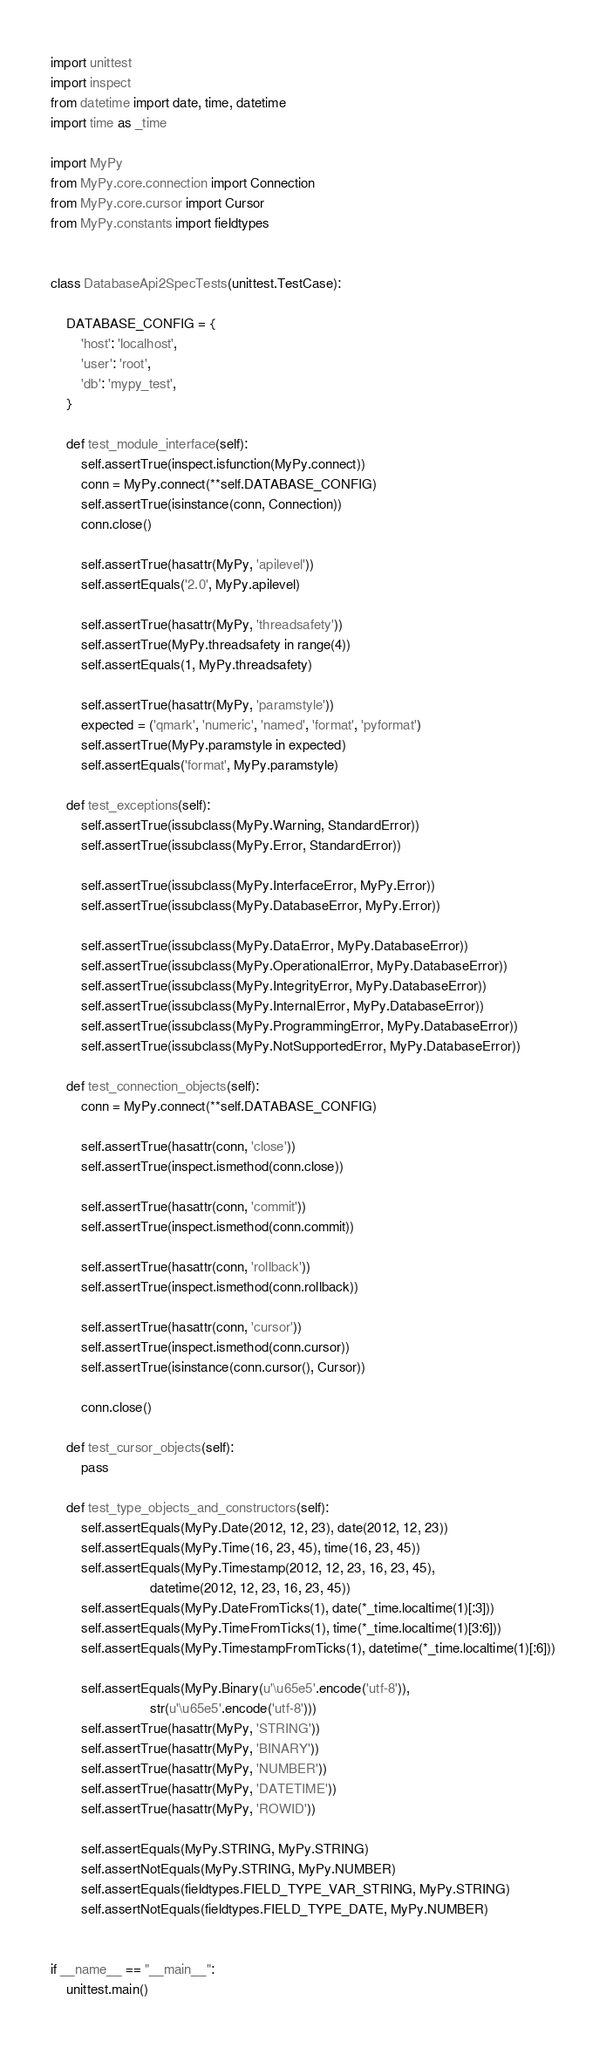Convert code to text. <code><loc_0><loc_0><loc_500><loc_500><_Python_>import unittest   
import inspect
from datetime import date, time, datetime
import time as _time

import MyPy
from MyPy.core.connection import Connection
from MyPy.core.cursor import Cursor
from MyPy.constants import fieldtypes


class DatabaseApi2SpecTests(unittest.TestCase):
    
    DATABASE_CONFIG = {
        'host': 'localhost',
        'user': 'root',
        'db': 'mypy_test',
    }
     
    def test_module_interface(self):
        self.assertTrue(inspect.isfunction(MyPy.connect))
        conn = MyPy.connect(**self.DATABASE_CONFIG)
        self.assertTrue(isinstance(conn, Connection))
        conn.close()

        self.assertTrue(hasattr(MyPy, 'apilevel'))
        self.assertEquals('2.0', MyPy.apilevel)
        
        self.assertTrue(hasattr(MyPy, 'threadsafety'))
        self.assertTrue(MyPy.threadsafety in range(4))
        self.assertEquals(1, MyPy.threadsafety)
        
        self.assertTrue(hasattr(MyPy, 'paramstyle'))
        expected = ('qmark', 'numeric', 'named', 'format', 'pyformat')
        self.assertTrue(MyPy.paramstyle in expected)
        self.assertEquals('format', MyPy.paramstyle)
        
    def test_exceptions(self):
        self.assertTrue(issubclass(MyPy.Warning, StandardError))
        self.assertTrue(issubclass(MyPy.Error, StandardError))
        
        self.assertTrue(issubclass(MyPy.InterfaceError, MyPy.Error))
        self.assertTrue(issubclass(MyPy.DatabaseError, MyPy.Error))

        self.assertTrue(issubclass(MyPy.DataError, MyPy.DatabaseError))
        self.assertTrue(issubclass(MyPy.OperationalError, MyPy.DatabaseError))
        self.assertTrue(issubclass(MyPy.IntegrityError, MyPy.DatabaseError))
        self.assertTrue(issubclass(MyPy.InternalError, MyPy.DatabaseError))
        self.assertTrue(issubclass(MyPy.ProgrammingError, MyPy.DatabaseError))
        self.assertTrue(issubclass(MyPy.NotSupportedError, MyPy.DatabaseError))

    def test_connection_objects(self):
        conn = MyPy.connect(**self.DATABASE_CONFIG)
    
        self.assertTrue(hasattr(conn, 'close'))
        self.assertTrue(inspect.ismethod(conn.close))
    
        self.assertTrue(hasattr(conn, 'commit'))
        self.assertTrue(inspect.ismethod(conn.commit))
    
        self.assertTrue(hasattr(conn, 'rollback'))
        self.assertTrue(inspect.ismethod(conn.rollback))
    
        self.assertTrue(hasattr(conn, 'cursor'))
        self.assertTrue(inspect.ismethod(conn.cursor))
        self.assertTrue(isinstance(conn.cursor(), Cursor))
        
        conn.close()
        
    def test_cursor_objects(self):
        pass

    def test_type_objects_and_constructors(self):
        self.assertEquals(MyPy.Date(2012, 12, 23), date(2012, 12, 23))
        self.assertEquals(MyPy.Time(16, 23, 45), time(16, 23, 45))
        self.assertEquals(MyPy.Timestamp(2012, 12, 23, 16, 23, 45), 
                          datetime(2012, 12, 23, 16, 23, 45))
        self.assertEquals(MyPy.DateFromTicks(1), date(*_time.localtime(1)[:3]))
        self.assertEquals(MyPy.TimeFromTicks(1), time(*_time.localtime(1)[3:6]))
        self.assertEquals(MyPy.TimestampFromTicks(1), datetime(*_time.localtime(1)[:6]))

        self.assertEquals(MyPy.Binary(u'\u65e5'.encode('utf-8')), 
                          str(u'\u65e5'.encode('utf-8')))
        self.assertTrue(hasattr(MyPy, 'STRING'))
        self.assertTrue(hasattr(MyPy, 'BINARY'))
        self.assertTrue(hasattr(MyPy, 'NUMBER'))
        self.assertTrue(hasattr(MyPy, 'DATETIME'))
        self.assertTrue(hasattr(MyPy, 'ROWID'))
        
        self.assertEquals(MyPy.STRING, MyPy.STRING)
        self.assertNotEquals(MyPy.STRING, MyPy.NUMBER)
        self.assertEquals(fieldtypes.FIELD_TYPE_VAR_STRING, MyPy.STRING)
        self.assertNotEquals(fieldtypes.FIELD_TYPE_DATE, MyPy.NUMBER)


if __name__ == "__main__":
    unittest.main()</code> 